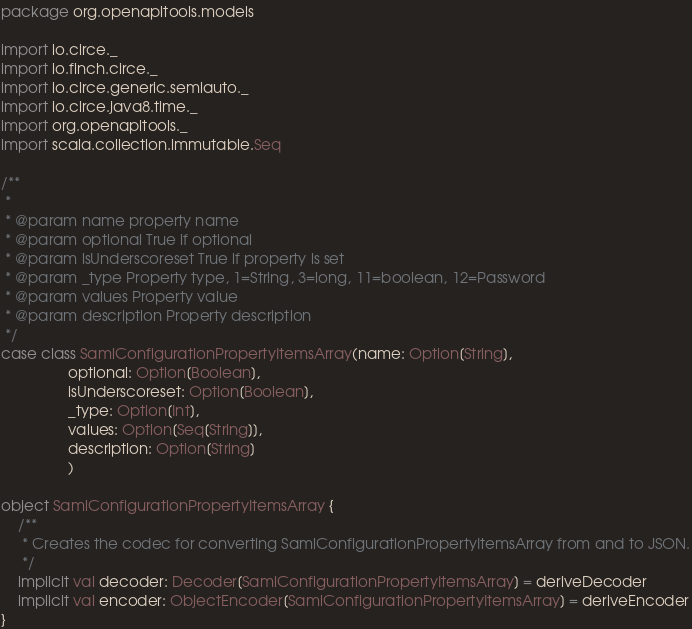Convert code to text. <code><loc_0><loc_0><loc_500><loc_500><_Scala_>package org.openapitools.models

import io.circe._
import io.finch.circe._
import io.circe.generic.semiauto._
import io.circe.java8.time._
import org.openapitools._
import scala.collection.immutable.Seq

/**
 * 
 * @param name property name
 * @param optional True if optional
 * @param isUnderscoreset True if property is set
 * @param _type Property type, 1=String, 3=long, 11=boolean, 12=Password
 * @param values Property value
 * @param description Property description
 */
case class SamlConfigurationPropertyItemsArray(name: Option[String],
                optional: Option[Boolean],
                isUnderscoreset: Option[Boolean],
                _type: Option[Int],
                values: Option[Seq[String]],
                description: Option[String]
                )

object SamlConfigurationPropertyItemsArray {
    /**
     * Creates the codec for converting SamlConfigurationPropertyItemsArray from and to JSON.
     */
    implicit val decoder: Decoder[SamlConfigurationPropertyItemsArray] = deriveDecoder
    implicit val encoder: ObjectEncoder[SamlConfigurationPropertyItemsArray] = deriveEncoder
}
</code> 